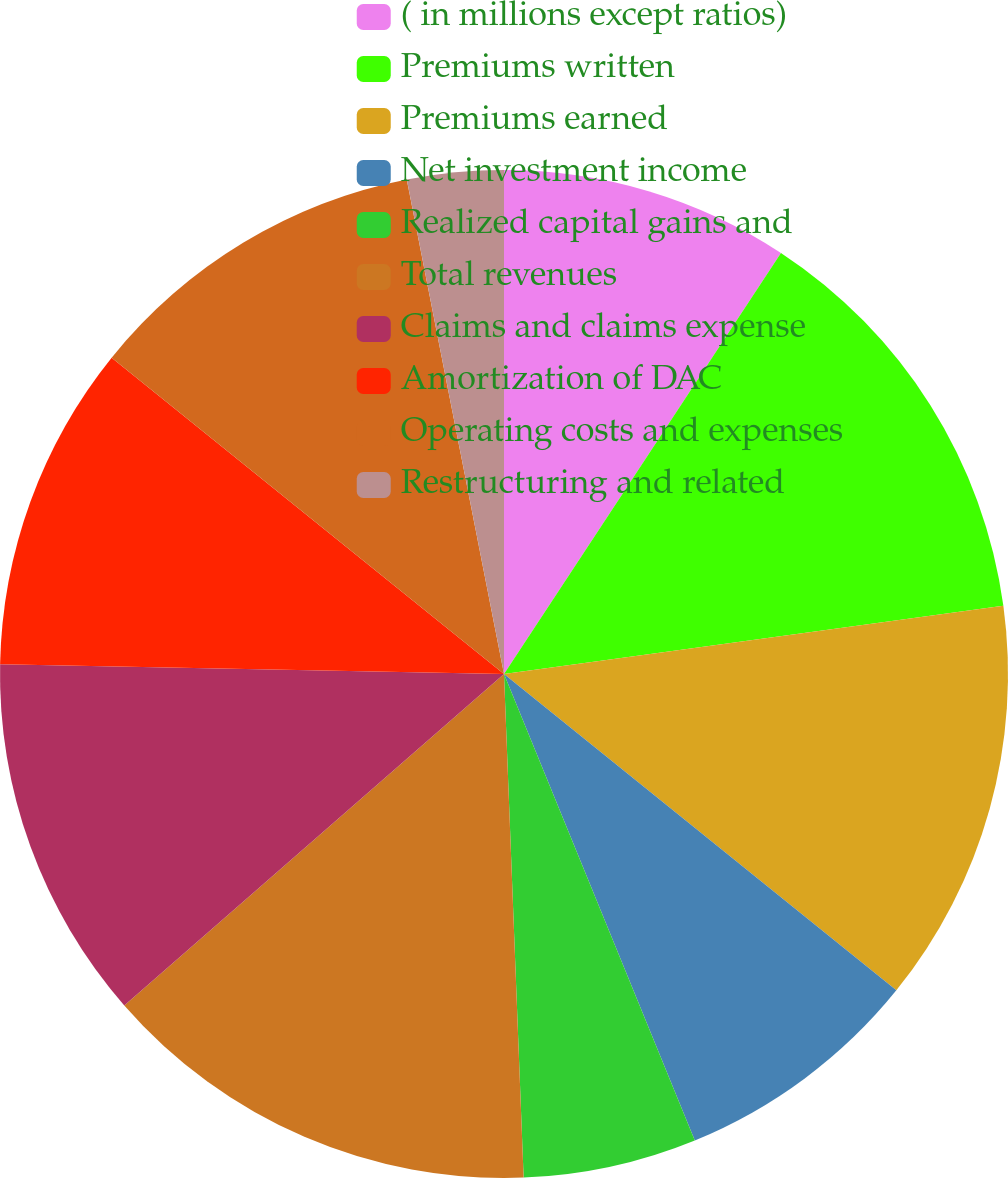Convert chart. <chart><loc_0><loc_0><loc_500><loc_500><pie_chart><fcel>( in millions except ratios)<fcel>Premiums written<fcel>Premiums earned<fcel>Net investment income<fcel>Realized capital gains and<fcel>Total revenues<fcel>Claims and claims expense<fcel>Amortization of DAC<fcel>Operating costs and expenses<fcel>Restructuring and related<nl><fcel>9.26%<fcel>13.58%<fcel>12.96%<fcel>8.02%<fcel>5.56%<fcel>14.2%<fcel>11.73%<fcel>10.49%<fcel>11.11%<fcel>3.09%<nl></chart> 